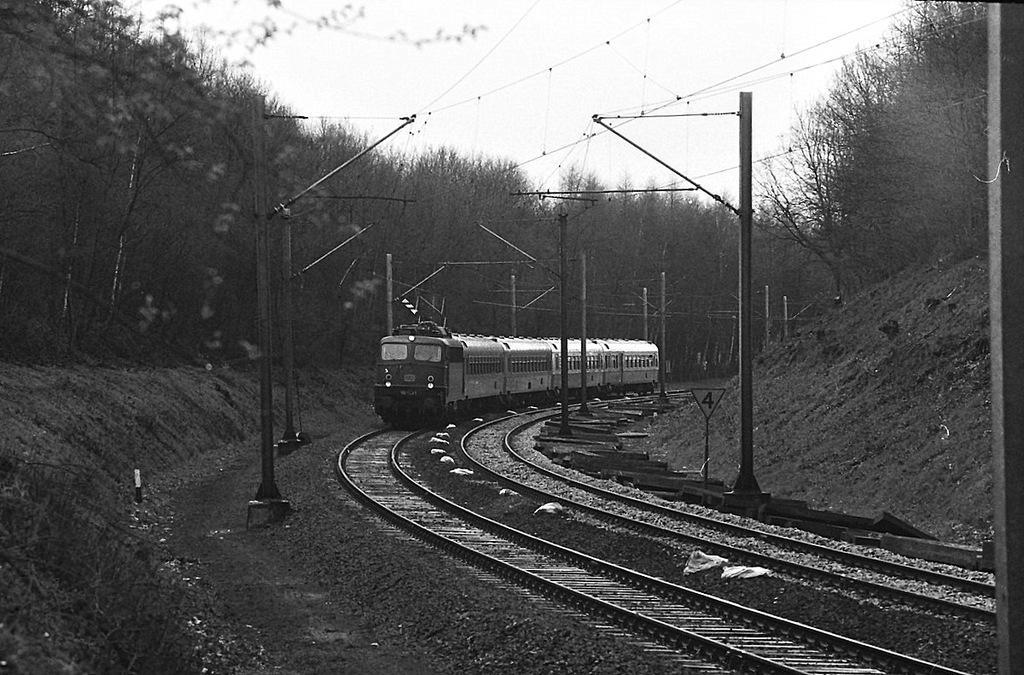Could you give a brief overview of what you see in this image? This image is taken outdoors. At the bottom of the image there is a ground and a railway track. At the top of the image there is a sky. In the middle of the image a train is moving on the track. On the left and right sides of the image there are many trees and a few poles with wires. 